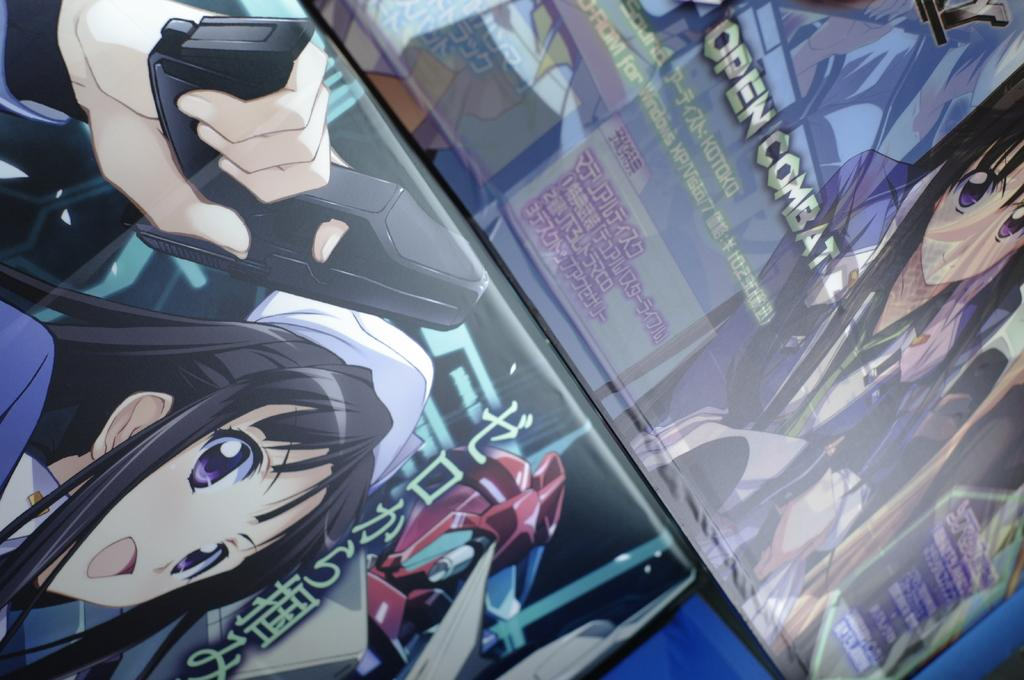What objects are present in the image? There are boards in the image. What is depicted on the boards? The boards have animated images on them. Are there any words or phrases on the boards? Yes, there is text on the boards. What type of lace can be seen on the boards in the image? There is no lace present on the boards in the image. Can you hear the bell ringing in the image? There is no bell present in the image, so it cannot be heard. 